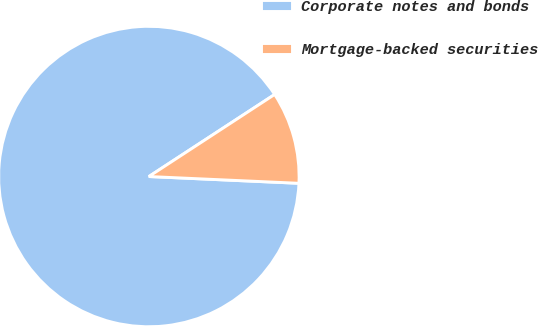Convert chart. <chart><loc_0><loc_0><loc_500><loc_500><pie_chart><fcel>Corporate notes and bonds<fcel>Mortgage-backed securities<nl><fcel>90.08%<fcel>9.92%<nl></chart> 